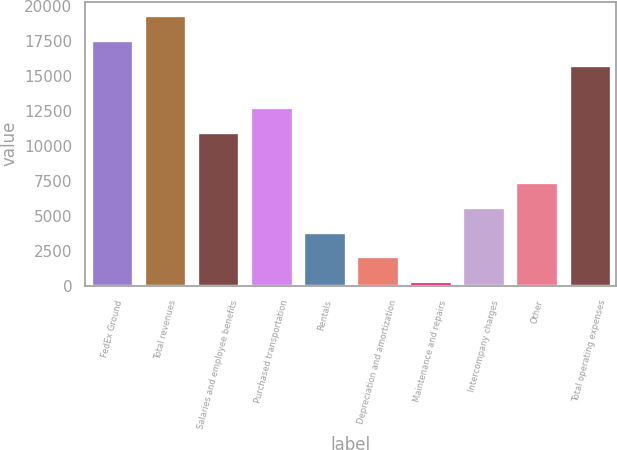Convert chart. <chart><loc_0><loc_0><loc_500><loc_500><bar_chart><fcel>FedEx Ground<fcel>Total revenues<fcel>Salaries and employee benefits<fcel>Purchased transportation<fcel>Rentals<fcel>Depreciation and amortization<fcel>Maintenance and repairs<fcel>Intercompany charges<fcel>Other<fcel>Total operating expenses<nl><fcel>17558.3<fcel>19333.6<fcel>10973.8<fcel>12749.1<fcel>3872.6<fcel>2097.3<fcel>322<fcel>5647.9<fcel>7423.2<fcel>15783<nl></chart> 